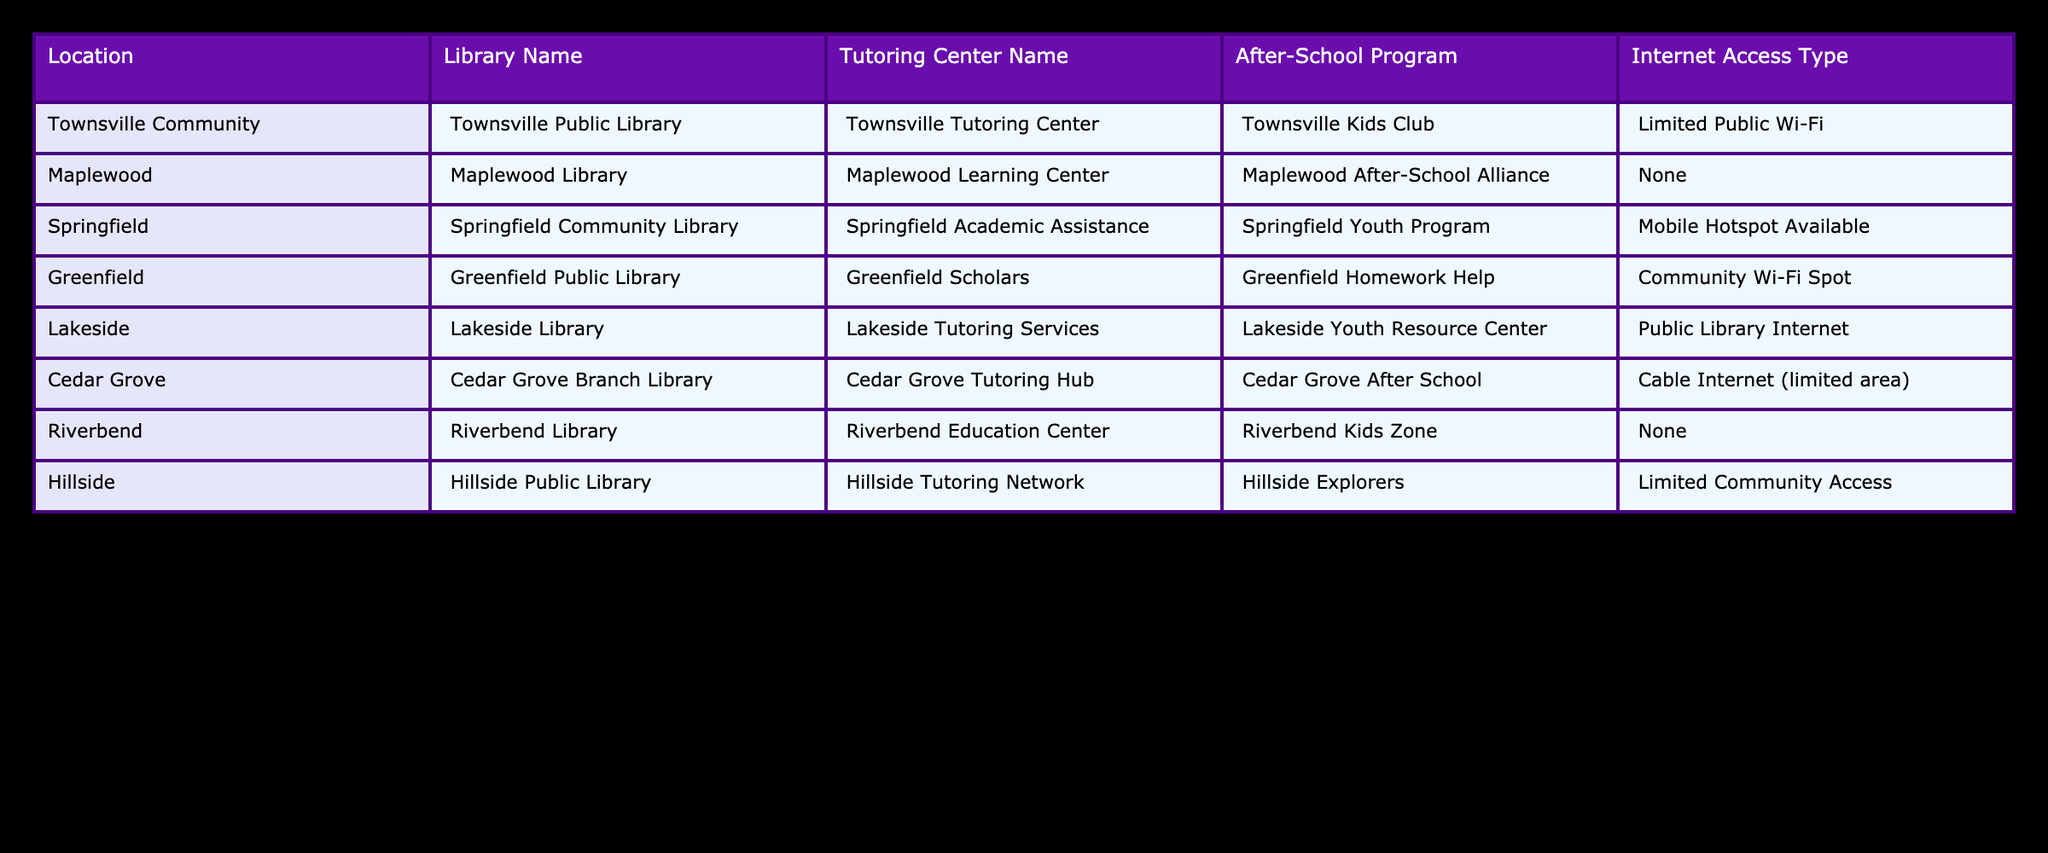What library is available in Springfield? The table lists the library names by location. Looking at the row for Springfield, the library mentioned is Springfield Community Library.
Answer: Springfield Community Library Which location has the best internet access type? By examining the "Internet Access Type" column across all locations, the best option looks like "Cable Internet (limited area)" at Cedar Grove, as it provides a more stable internet connection compared to others.
Answer: Cedar Grove Do Townsville and Maplewood both have tutoring centers? In the table, the "Tutoring Center Name" for Townsville is Townsville Tutoring Center, while Maplewood's is Maplewood Learning Center. Both locations have tutoring centers available.
Answer: Yes How many locations have no internet access? I count the rows in the table for locations with "None" listed under the "Internet Access Type." The locations without internet access are Maplewood and Riverbend, giving us a total of 2 locations with no internet access.
Answer: 2 Which locations offer both a library and an after-school program? To determine this, I will check the rows where both library names and after-school program names are listed. The locations that meet this criteria are Townsville Community, Maplewood, Springfield, Greenfield, Lakeside, and Cedar Grove. This is a total of 6 locations that offer both services.
Answer: 6 Is there a location with more than one type of internet access? The table shows internet access for each location, and only Cedar Grove has "Cable Internet (limited area)," indicating a more complex access type compared to others which mostly have a singular option or none. Therefore, no location exceeds one type of access.
Answer: No What is the average number of community resources (libraries + tutoring centers + after-school programs) across the listed locations? First, I will count the number of resources for each location: Townsville (4), Maplewood (3), Springfield (3), Greenfield (3), Lakeside (3), Cedar Grove (3), Riverbend (3), and Hillside (3). Adding these gives us 24 resources, then divide by 8 locations to find the average: 24 / 8 = 3.
Answer: 3 Which location's after-school program has the most unique name? By reviewing the "After-School Program" names in the table, "Townsville Kids Club" stands out with a unique, appealing name compared to others. Names like "Homework Help" or "Explorers" are more generic.
Answer: Townsville Kids Club How many locations offer community after-school programs? I will examine the "After-School Program" column to see which ones are listed. The following have after-school programs: Townsville, Maplewood, Springfield, Greenfield, Lakeside, Cedar Grove, and Hillside, amounting to 7 locations in total.
Answer: 7 